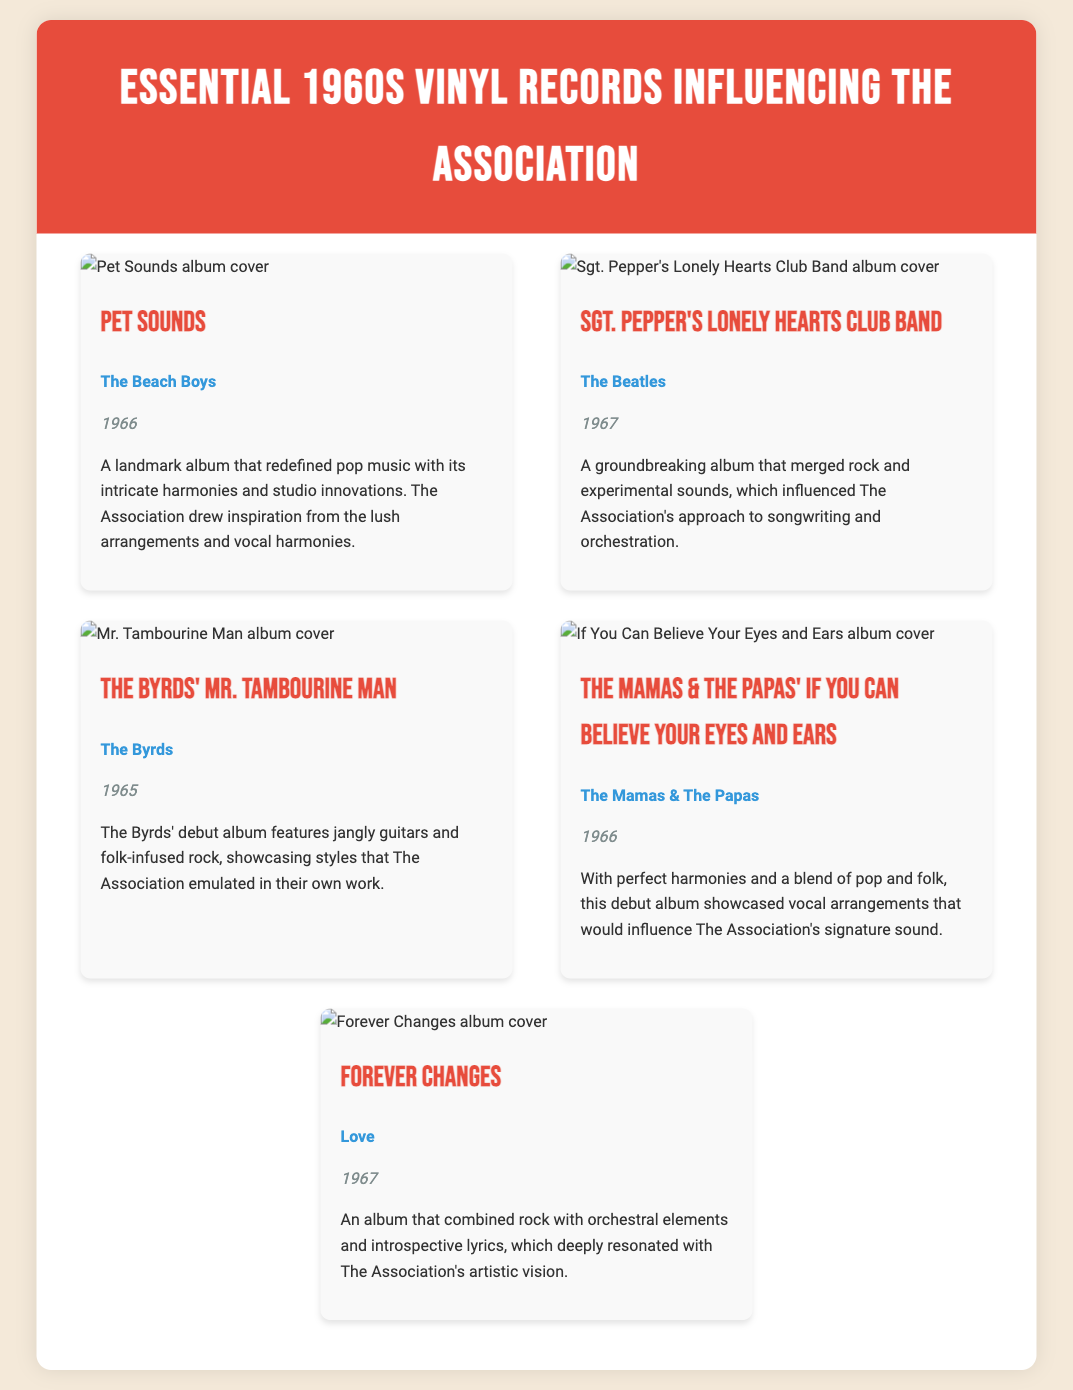What is the title of the first album listed? The first album in the document is "Pet Sounds."
Answer: Pet Sounds Who is the artist of the album "Forever Changes"? The document states that the artist of "Forever Changes" is Love.
Answer: Love What year was "Sgt. Pepper's Lonely Hearts Club Band" released? The release year for "Sgt. Pepper's Lonely Hearts Club Band" is noted as 1967.
Answer: 1967 What type of musical elements does "Forever Changes" combine? The description mentions that "Forever Changes" combines rock with orchestral elements.
Answer: Rock and orchestral elements Which album is noted for redefined pop music with its intricate harmonies? According to the document, "Pet Sounds" is recognized for redefining pop music with intricate harmonies.
Answer: Pet Sounds How many records are listed in total? The document features a total of five albums.
Answer: Five Which artist's debut album was described in connection to jangly guitars and folk-infused rock? The document associates The Byrds' debut album with jangly guitars and folk-infused rock.
Answer: The Byrds What album reflects a blend of pop and folk with perfect harmonies according to the document? The document references "If You Can Believe Your Eyes and Ears" for its perfect harmonies and pop-folk blend.
Answer: If You Can Believe Your Eyes and Ears 